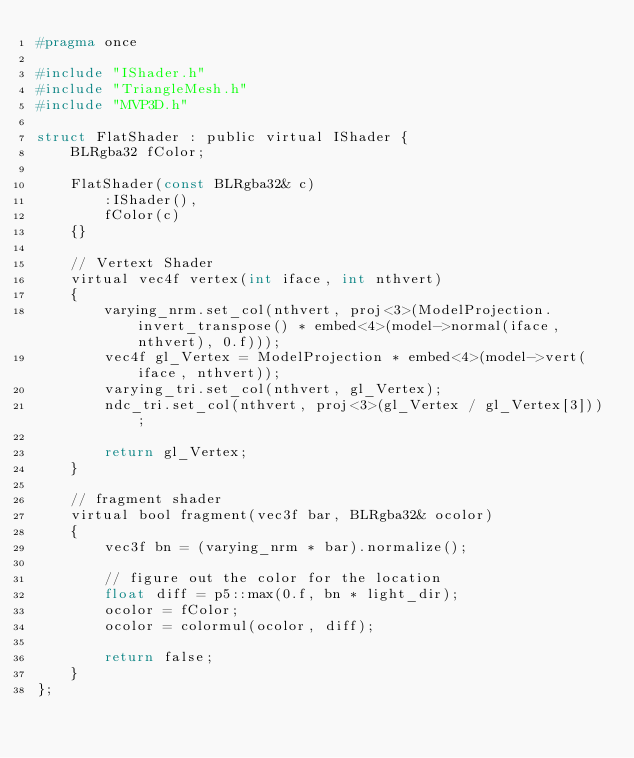<code> <loc_0><loc_0><loc_500><loc_500><_C_>#pragma once

#include "IShader.h"
#include "TriangleMesh.h"
#include "MVP3D.h"

struct FlatShader : public virtual IShader {
	BLRgba32 fColor;

	FlatShader(const BLRgba32& c)
		:IShader(),
		fColor(c)
	{}

	// Vertext Shader
	virtual vec4f vertex(int iface, int nthvert)
	{
		varying_nrm.set_col(nthvert, proj<3>(ModelProjection.invert_transpose() * embed<4>(model->normal(iface, nthvert), 0.f)));
		vec4f gl_Vertex = ModelProjection * embed<4>(model->vert(iface, nthvert));
		varying_tri.set_col(nthvert, gl_Vertex);
		ndc_tri.set_col(nthvert, proj<3>(gl_Vertex / gl_Vertex[3]));

		return gl_Vertex;
	}

	// fragment shader
	virtual bool fragment(vec3f bar, BLRgba32& ocolor)
	{
		vec3f bn = (varying_nrm * bar).normalize();

		// figure out the color for the location
		float diff = p5::max(0.f, bn * light_dir);
		ocolor = fColor;
		ocolor = colormul(ocolor, diff);

		return false;
	}
};

</code> 